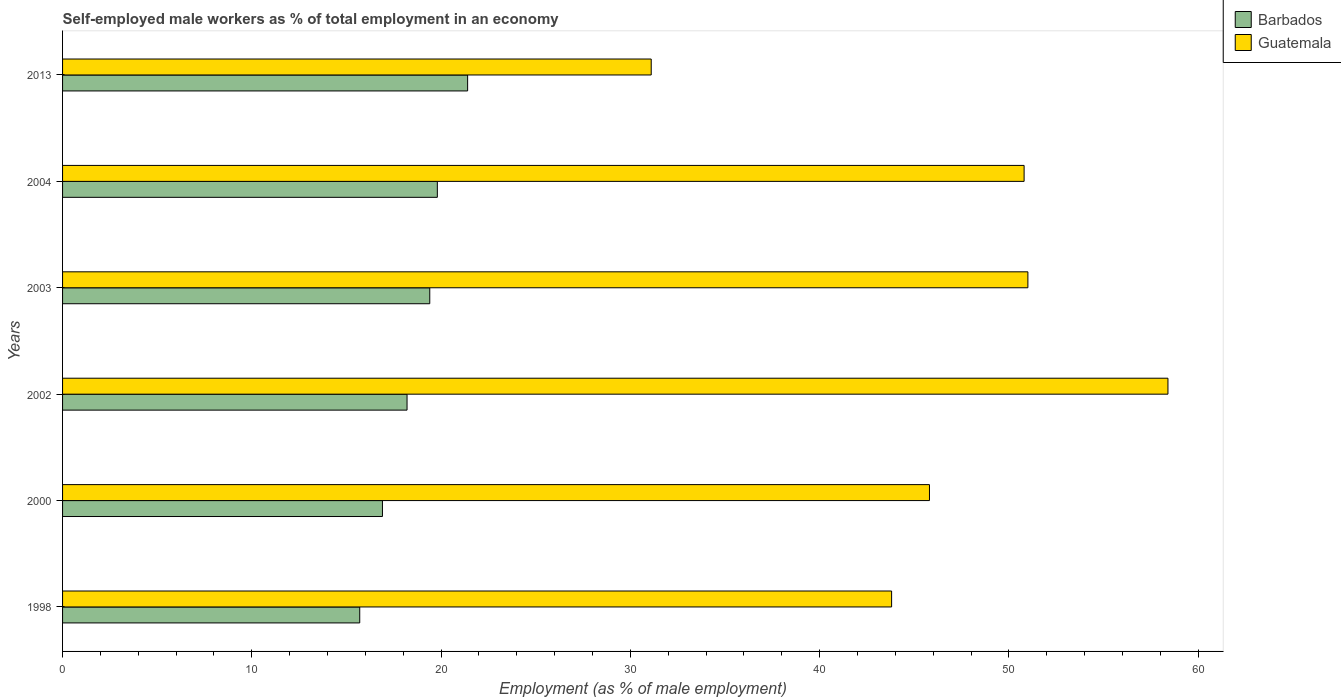Are the number of bars on each tick of the Y-axis equal?
Offer a very short reply. Yes. How many bars are there on the 5th tick from the bottom?
Make the answer very short. 2. What is the label of the 3rd group of bars from the top?
Ensure brevity in your answer.  2003. In how many cases, is the number of bars for a given year not equal to the number of legend labels?
Keep it short and to the point. 0. What is the percentage of self-employed male workers in Barbados in 1998?
Offer a very short reply. 15.7. Across all years, what is the maximum percentage of self-employed male workers in Guatemala?
Give a very brief answer. 58.4. Across all years, what is the minimum percentage of self-employed male workers in Guatemala?
Your answer should be very brief. 31.1. In which year was the percentage of self-employed male workers in Guatemala minimum?
Offer a very short reply. 2013. What is the total percentage of self-employed male workers in Guatemala in the graph?
Give a very brief answer. 280.9. What is the difference between the percentage of self-employed male workers in Barbados in 1998 and that in 2000?
Your answer should be compact. -1.2. What is the difference between the percentage of self-employed male workers in Guatemala in 2013 and the percentage of self-employed male workers in Barbados in 2002?
Your response must be concise. 12.9. What is the average percentage of self-employed male workers in Barbados per year?
Give a very brief answer. 18.57. In the year 2000, what is the difference between the percentage of self-employed male workers in Guatemala and percentage of self-employed male workers in Barbados?
Provide a succinct answer. 28.9. In how many years, is the percentage of self-employed male workers in Guatemala greater than 48 %?
Provide a succinct answer. 3. What is the ratio of the percentage of self-employed male workers in Guatemala in 2000 to that in 2003?
Your response must be concise. 0.9. What is the difference between the highest and the second highest percentage of self-employed male workers in Guatemala?
Offer a very short reply. 7.4. What is the difference between the highest and the lowest percentage of self-employed male workers in Barbados?
Your answer should be compact. 5.7. Is the sum of the percentage of self-employed male workers in Barbados in 2000 and 2004 greater than the maximum percentage of self-employed male workers in Guatemala across all years?
Your response must be concise. No. What does the 1st bar from the top in 1998 represents?
Offer a terse response. Guatemala. What does the 2nd bar from the bottom in 2003 represents?
Give a very brief answer. Guatemala. Are all the bars in the graph horizontal?
Your answer should be very brief. Yes. How many years are there in the graph?
Offer a terse response. 6. What is the difference between two consecutive major ticks on the X-axis?
Give a very brief answer. 10. Are the values on the major ticks of X-axis written in scientific E-notation?
Your answer should be very brief. No. Does the graph contain any zero values?
Your answer should be compact. No. Where does the legend appear in the graph?
Your answer should be compact. Top right. What is the title of the graph?
Your response must be concise. Self-employed male workers as % of total employment in an economy. Does "Bolivia" appear as one of the legend labels in the graph?
Your answer should be very brief. No. What is the label or title of the X-axis?
Make the answer very short. Employment (as % of male employment). What is the label or title of the Y-axis?
Give a very brief answer. Years. What is the Employment (as % of male employment) in Barbados in 1998?
Provide a short and direct response. 15.7. What is the Employment (as % of male employment) of Guatemala in 1998?
Make the answer very short. 43.8. What is the Employment (as % of male employment) in Barbados in 2000?
Your answer should be very brief. 16.9. What is the Employment (as % of male employment) of Guatemala in 2000?
Your answer should be compact. 45.8. What is the Employment (as % of male employment) in Barbados in 2002?
Provide a succinct answer. 18.2. What is the Employment (as % of male employment) in Guatemala in 2002?
Keep it short and to the point. 58.4. What is the Employment (as % of male employment) in Barbados in 2003?
Your response must be concise. 19.4. What is the Employment (as % of male employment) in Guatemala in 2003?
Make the answer very short. 51. What is the Employment (as % of male employment) of Barbados in 2004?
Your answer should be compact. 19.8. What is the Employment (as % of male employment) of Guatemala in 2004?
Make the answer very short. 50.8. What is the Employment (as % of male employment) of Barbados in 2013?
Give a very brief answer. 21.4. What is the Employment (as % of male employment) of Guatemala in 2013?
Ensure brevity in your answer.  31.1. Across all years, what is the maximum Employment (as % of male employment) in Barbados?
Offer a very short reply. 21.4. Across all years, what is the maximum Employment (as % of male employment) in Guatemala?
Offer a very short reply. 58.4. Across all years, what is the minimum Employment (as % of male employment) in Barbados?
Keep it short and to the point. 15.7. Across all years, what is the minimum Employment (as % of male employment) in Guatemala?
Offer a very short reply. 31.1. What is the total Employment (as % of male employment) in Barbados in the graph?
Offer a very short reply. 111.4. What is the total Employment (as % of male employment) in Guatemala in the graph?
Ensure brevity in your answer.  280.9. What is the difference between the Employment (as % of male employment) of Barbados in 1998 and that in 2000?
Provide a succinct answer. -1.2. What is the difference between the Employment (as % of male employment) of Guatemala in 1998 and that in 2000?
Provide a succinct answer. -2. What is the difference between the Employment (as % of male employment) in Guatemala in 1998 and that in 2002?
Provide a short and direct response. -14.6. What is the difference between the Employment (as % of male employment) in Barbados in 1998 and that in 2003?
Give a very brief answer. -3.7. What is the difference between the Employment (as % of male employment) of Guatemala in 1998 and that in 2004?
Provide a short and direct response. -7. What is the difference between the Employment (as % of male employment) in Barbados in 1998 and that in 2013?
Your response must be concise. -5.7. What is the difference between the Employment (as % of male employment) in Guatemala in 1998 and that in 2013?
Offer a very short reply. 12.7. What is the difference between the Employment (as % of male employment) in Barbados in 2000 and that in 2002?
Give a very brief answer. -1.3. What is the difference between the Employment (as % of male employment) of Barbados in 2000 and that in 2004?
Keep it short and to the point. -2.9. What is the difference between the Employment (as % of male employment) of Guatemala in 2000 and that in 2004?
Ensure brevity in your answer.  -5. What is the difference between the Employment (as % of male employment) in Guatemala in 2000 and that in 2013?
Keep it short and to the point. 14.7. What is the difference between the Employment (as % of male employment) in Guatemala in 2002 and that in 2003?
Make the answer very short. 7.4. What is the difference between the Employment (as % of male employment) of Barbados in 2002 and that in 2013?
Offer a very short reply. -3.2. What is the difference between the Employment (as % of male employment) of Guatemala in 2002 and that in 2013?
Provide a short and direct response. 27.3. What is the difference between the Employment (as % of male employment) in Barbados in 2003 and that in 2013?
Give a very brief answer. -2. What is the difference between the Employment (as % of male employment) in Guatemala in 2004 and that in 2013?
Your answer should be compact. 19.7. What is the difference between the Employment (as % of male employment) of Barbados in 1998 and the Employment (as % of male employment) of Guatemala in 2000?
Make the answer very short. -30.1. What is the difference between the Employment (as % of male employment) in Barbados in 1998 and the Employment (as % of male employment) in Guatemala in 2002?
Your answer should be very brief. -42.7. What is the difference between the Employment (as % of male employment) of Barbados in 1998 and the Employment (as % of male employment) of Guatemala in 2003?
Your response must be concise. -35.3. What is the difference between the Employment (as % of male employment) in Barbados in 1998 and the Employment (as % of male employment) in Guatemala in 2004?
Your response must be concise. -35.1. What is the difference between the Employment (as % of male employment) in Barbados in 1998 and the Employment (as % of male employment) in Guatemala in 2013?
Offer a terse response. -15.4. What is the difference between the Employment (as % of male employment) of Barbados in 2000 and the Employment (as % of male employment) of Guatemala in 2002?
Offer a very short reply. -41.5. What is the difference between the Employment (as % of male employment) of Barbados in 2000 and the Employment (as % of male employment) of Guatemala in 2003?
Your response must be concise. -34.1. What is the difference between the Employment (as % of male employment) of Barbados in 2000 and the Employment (as % of male employment) of Guatemala in 2004?
Your answer should be very brief. -33.9. What is the difference between the Employment (as % of male employment) in Barbados in 2002 and the Employment (as % of male employment) in Guatemala in 2003?
Offer a very short reply. -32.8. What is the difference between the Employment (as % of male employment) of Barbados in 2002 and the Employment (as % of male employment) of Guatemala in 2004?
Your answer should be very brief. -32.6. What is the difference between the Employment (as % of male employment) of Barbados in 2003 and the Employment (as % of male employment) of Guatemala in 2004?
Give a very brief answer. -31.4. What is the difference between the Employment (as % of male employment) in Barbados in 2004 and the Employment (as % of male employment) in Guatemala in 2013?
Provide a short and direct response. -11.3. What is the average Employment (as % of male employment) in Barbados per year?
Offer a very short reply. 18.57. What is the average Employment (as % of male employment) in Guatemala per year?
Your answer should be very brief. 46.82. In the year 1998, what is the difference between the Employment (as % of male employment) in Barbados and Employment (as % of male employment) in Guatemala?
Your answer should be compact. -28.1. In the year 2000, what is the difference between the Employment (as % of male employment) in Barbados and Employment (as % of male employment) in Guatemala?
Your answer should be compact. -28.9. In the year 2002, what is the difference between the Employment (as % of male employment) of Barbados and Employment (as % of male employment) of Guatemala?
Keep it short and to the point. -40.2. In the year 2003, what is the difference between the Employment (as % of male employment) of Barbados and Employment (as % of male employment) of Guatemala?
Your answer should be compact. -31.6. In the year 2004, what is the difference between the Employment (as % of male employment) in Barbados and Employment (as % of male employment) in Guatemala?
Keep it short and to the point. -31. In the year 2013, what is the difference between the Employment (as % of male employment) in Barbados and Employment (as % of male employment) in Guatemala?
Provide a succinct answer. -9.7. What is the ratio of the Employment (as % of male employment) of Barbados in 1998 to that in 2000?
Give a very brief answer. 0.93. What is the ratio of the Employment (as % of male employment) of Guatemala in 1998 to that in 2000?
Keep it short and to the point. 0.96. What is the ratio of the Employment (as % of male employment) in Barbados in 1998 to that in 2002?
Provide a short and direct response. 0.86. What is the ratio of the Employment (as % of male employment) of Barbados in 1998 to that in 2003?
Provide a short and direct response. 0.81. What is the ratio of the Employment (as % of male employment) of Guatemala in 1998 to that in 2003?
Ensure brevity in your answer.  0.86. What is the ratio of the Employment (as % of male employment) in Barbados in 1998 to that in 2004?
Your answer should be compact. 0.79. What is the ratio of the Employment (as % of male employment) in Guatemala in 1998 to that in 2004?
Provide a short and direct response. 0.86. What is the ratio of the Employment (as % of male employment) of Barbados in 1998 to that in 2013?
Give a very brief answer. 0.73. What is the ratio of the Employment (as % of male employment) of Guatemala in 1998 to that in 2013?
Offer a terse response. 1.41. What is the ratio of the Employment (as % of male employment) in Barbados in 2000 to that in 2002?
Give a very brief answer. 0.93. What is the ratio of the Employment (as % of male employment) of Guatemala in 2000 to that in 2002?
Offer a very short reply. 0.78. What is the ratio of the Employment (as % of male employment) in Barbados in 2000 to that in 2003?
Offer a terse response. 0.87. What is the ratio of the Employment (as % of male employment) in Guatemala in 2000 to that in 2003?
Offer a terse response. 0.9. What is the ratio of the Employment (as % of male employment) of Barbados in 2000 to that in 2004?
Give a very brief answer. 0.85. What is the ratio of the Employment (as % of male employment) in Guatemala in 2000 to that in 2004?
Provide a succinct answer. 0.9. What is the ratio of the Employment (as % of male employment) of Barbados in 2000 to that in 2013?
Your answer should be very brief. 0.79. What is the ratio of the Employment (as % of male employment) of Guatemala in 2000 to that in 2013?
Provide a succinct answer. 1.47. What is the ratio of the Employment (as % of male employment) in Barbados in 2002 to that in 2003?
Provide a succinct answer. 0.94. What is the ratio of the Employment (as % of male employment) of Guatemala in 2002 to that in 2003?
Make the answer very short. 1.15. What is the ratio of the Employment (as % of male employment) of Barbados in 2002 to that in 2004?
Your response must be concise. 0.92. What is the ratio of the Employment (as % of male employment) of Guatemala in 2002 to that in 2004?
Give a very brief answer. 1.15. What is the ratio of the Employment (as % of male employment) in Barbados in 2002 to that in 2013?
Keep it short and to the point. 0.85. What is the ratio of the Employment (as % of male employment) in Guatemala in 2002 to that in 2013?
Your response must be concise. 1.88. What is the ratio of the Employment (as % of male employment) of Barbados in 2003 to that in 2004?
Your response must be concise. 0.98. What is the ratio of the Employment (as % of male employment) of Barbados in 2003 to that in 2013?
Ensure brevity in your answer.  0.91. What is the ratio of the Employment (as % of male employment) of Guatemala in 2003 to that in 2013?
Your response must be concise. 1.64. What is the ratio of the Employment (as % of male employment) of Barbados in 2004 to that in 2013?
Provide a succinct answer. 0.93. What is the ratio of the Employment (as % of male employment) of Guatemala in 2004 to that in 2013?
Your response must be concise. 1.63. What is the difference between the highest and the second highest Employment (as % of male employment) of Barbados?
Ensure brevity in your answer.  1.6. What is the difference between the highest and the lowest Employment (as % of male employment) of Guatemala?
Make the answer very short. 27.3. 